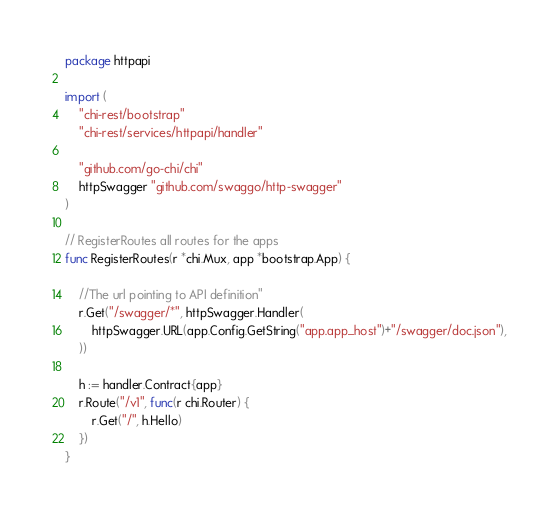<code> <loc_0><loc_0><loc_500><loc_500><_Go_>package httpapi

import (
	"chi-rest/bootstrap"
	"chi-rest/services/httpapi/handler"

	"github.com/go-chi/chi"
	httpSwagger "github.com/swaggo/http-swagger"
)

// RegisterRoutes all routes for the apps
func RegisterRoutes(r *chi.Mux, app *bootstrap.App) {

	//The url pointing to API definition"
	r.Get("/swagger/*", httpSwagger.Handler(
		httpSwagger.URL(app.Config.GetString("app.app_host")+"/swagger/doc.json"),
	))

	h := handler.Contract{app}
	r.Route("/v1", func(r chi.Router) {
		r.Get("/", h.Hello)
	})
}
</code> 